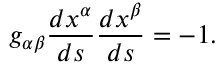Convert formula to latex. <formula><loc_0><loc_0><loc_500><loc_500>{ g _ { \alpha \beta } } { \frac { d x ^ { \alpha } } { d s } } { \frac { d x ^ { \beta } } { d s } } = - 1 .</formula> 